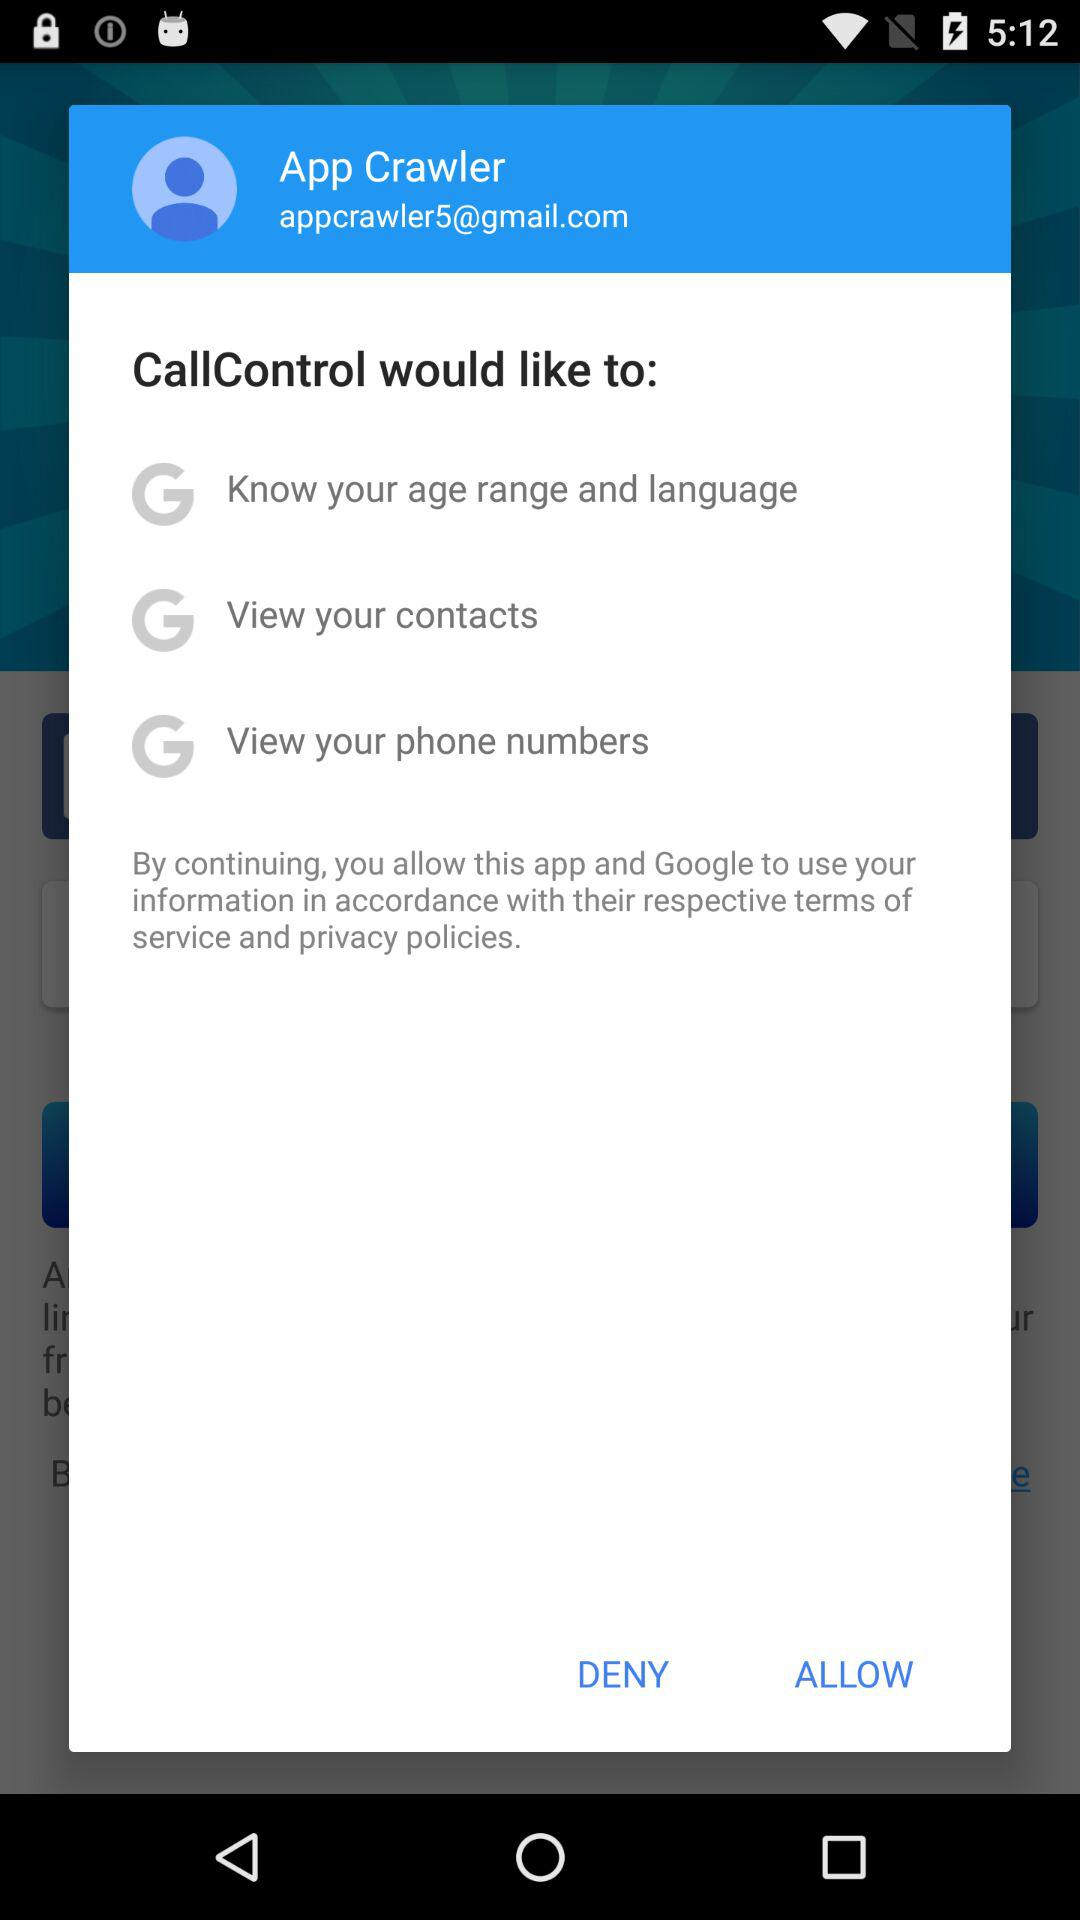What is the email address? The email address is appcrawler5@gmail.com. 